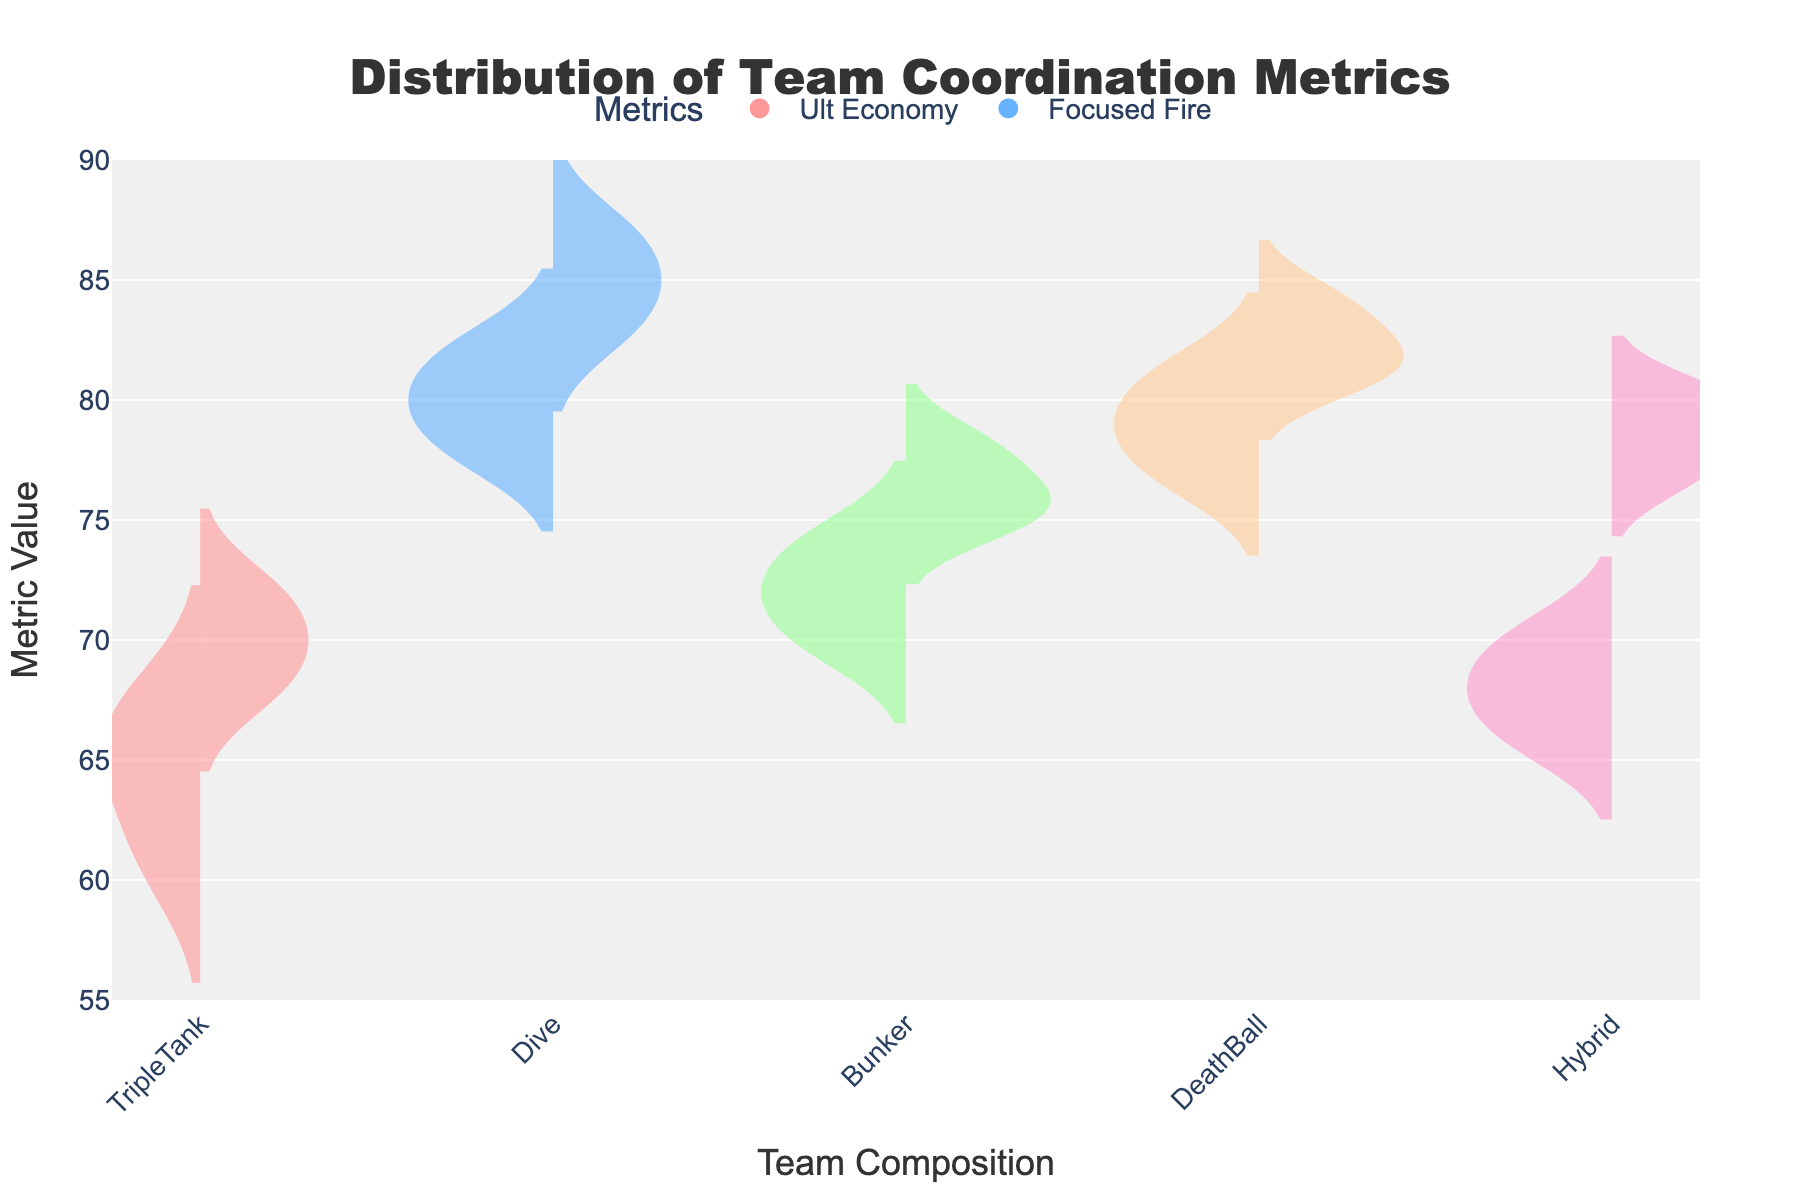What is the title of the plot? The title of the plot is displayed at the top center and reads 'Distribution of Team Coordination Metrics'.
Answer: Distribution of Team Coordination Metrics Which team composition has the highest median value for Ult Economy? To find the highest median value for Ult Economy, we look at the thick line inside each Ult Economy plot of different team compositions. The Dive composition has the highest median value, around 85.
Answer: Dive Are Ult Economy and Focused Fire metrics for the Hybrid team composition generally above or below 75? By examining the Violin plots, we see that Ult Economy values for Hybrid are centered around a median below 75, and the Focused Fire values are also generally below 75.
Answer: Below 75 Which team composition shows the most symmetrical distribution for Focused Fire? Symmetry can be observed by how evenly the values are spread out from the median line within the violin plot. The Bunker composition appears to have the most symmetrical distribution for Focused Fire as its values spread evenly from the median.
Answer: Bunker Between Dive and DeathBall team compositions, which has the greater average Ult Economy value? To determine the average Ult Economy, observe the position of the mean line (visible using a dashed line). For both Dive and DeathBall, the mean Ult Economy appears higher for Dive than for DeathBall.
Answer: Dive What range does the Focused Fire metric for TripleTank span? To find the range for TripleTank's Focused Fire, observe the top and bottom extent of the TripleTank's Focused Fire plot. The range spans from approximately 61 to 67.
Answer: 61 to 67 Which team composition has a more concentrated distribution of Ult Economy, where most values are close to the median? The concentration is determined by the width and shape of the Violin plot around the median line. The Hybrid composition shows a more concentrated Ult Economy distribution, where values cluster closely around the median.
Answer: Hybrid How many distinct team compositions are displayed on the plot? The x-axis lists all team compositions, and by counting them, we find there are five distinct team compositions: TripleTank, Dive, Bunker, DeathBall, and Hybrid.
Answer: Five What's the general distribution trend of Focused Fire metric for the DeathBall composition? The trend is observed by examining the shape and spread of the Violin plot for Focused Fire in DeathBall. It shows a relatively consistent and narrow spread around the median, hinting at a concentrated distribution.
Answer: Concentrated around median Between Bunker and Hybrid compositions, which has a higher variability in Focused Fire? Variability can be assessed by looking at the spread of the values in the Violin plot. Hybrid's Focused Fire has a wider range of values than Bunker, indicating higher variability.
Answer: Hybrid 